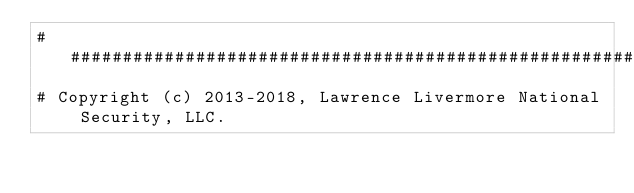<code> <loc_0><loc_0><loc_500><loc_500><_Python_>##############################################################################
# Copyright (c) 2013-2018, Lawrence Livermore National Security, LLC.</code> 